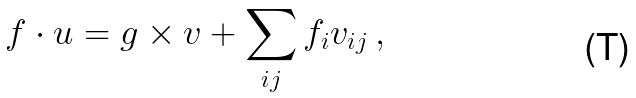Convert formula to latex. <formula><loc_0><loc_0><loc_500><loc_500>f \cdot u = g \times v + \sum _ { i j } f _ { i } v _ { i j } \, ,</formula> 